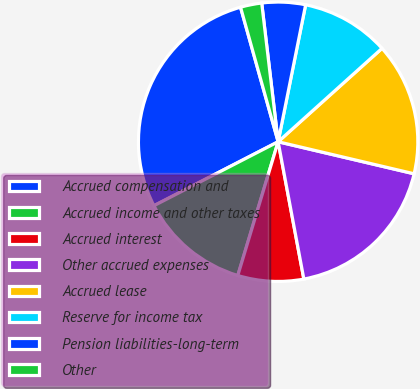Convert chart to OTSL. <chart><loc_0><loc_0><loc_500><loc_500><pie_chart><fcel>Accrued compensation and<fcel>Accrued income and other taxes<fcel>Accrued interest<fcel>Other accrued expenses<fcel>Accrued lease<fcel>Reserve for income tax<fcel>Pension liabilities-long-term<fcel>Other<nl><fcel>28.23%<fcel>12.77%<fcel>7.61%<fcel>18.37%<fcel>15.34%<fcel>10.19%<fcel>5.03%<fcel>2.46%<nl></chart> 